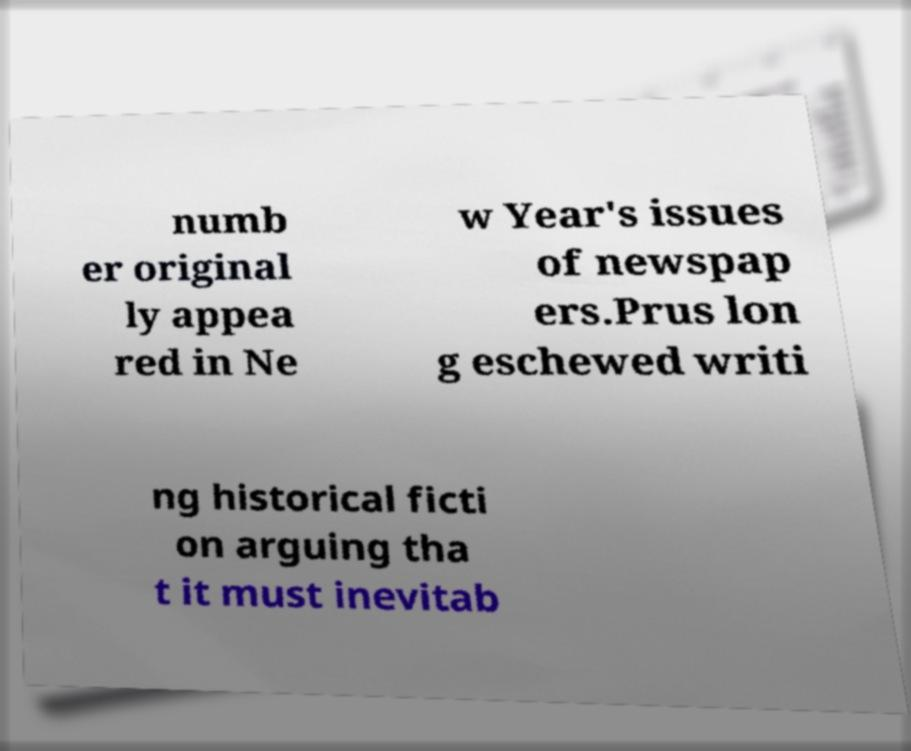Could you extract and type out the text from this image? numb er original ly appea red in Ne w Year's issues of newspap ers.Prus lon g eschewed writi ng historical ficti on arguing tha t it must inevitab 